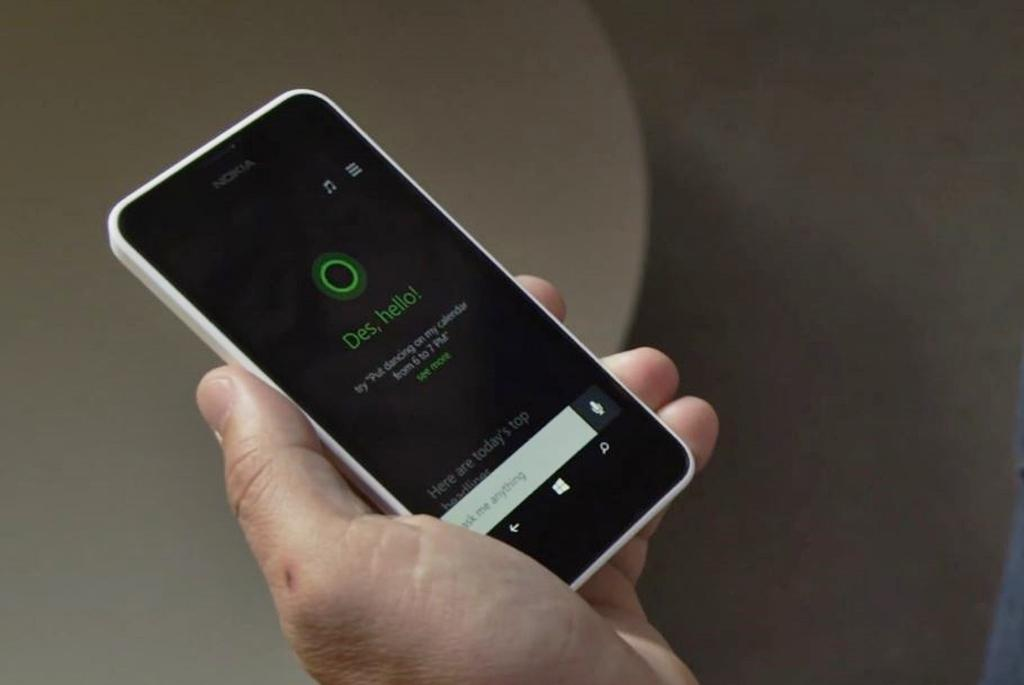<image>
Render a clear and concise summary of the photo. A person holding a white phone with black screen with an AI assistant saying hello. 